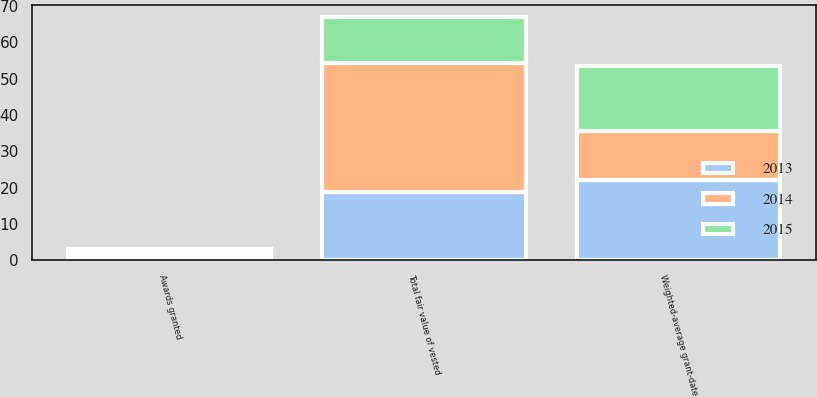<chart> <loc_0><loc_0><loc_500><loc_500><stacked_bar_chart><ecel><fcel>Awards granted<fcel>Weighted-average grant-date<fcel>Total fair value of vested<nl><fcel>2013<fcel>0.8<fcel>22.07<fcel>18.8<nl><fcel>2015<fcel>1.2<fcel>17.77<fcel>12.6<nl><fcel>2014<fcel>1.1<fcel>13.51<fcel>35.4<nl></chart> 